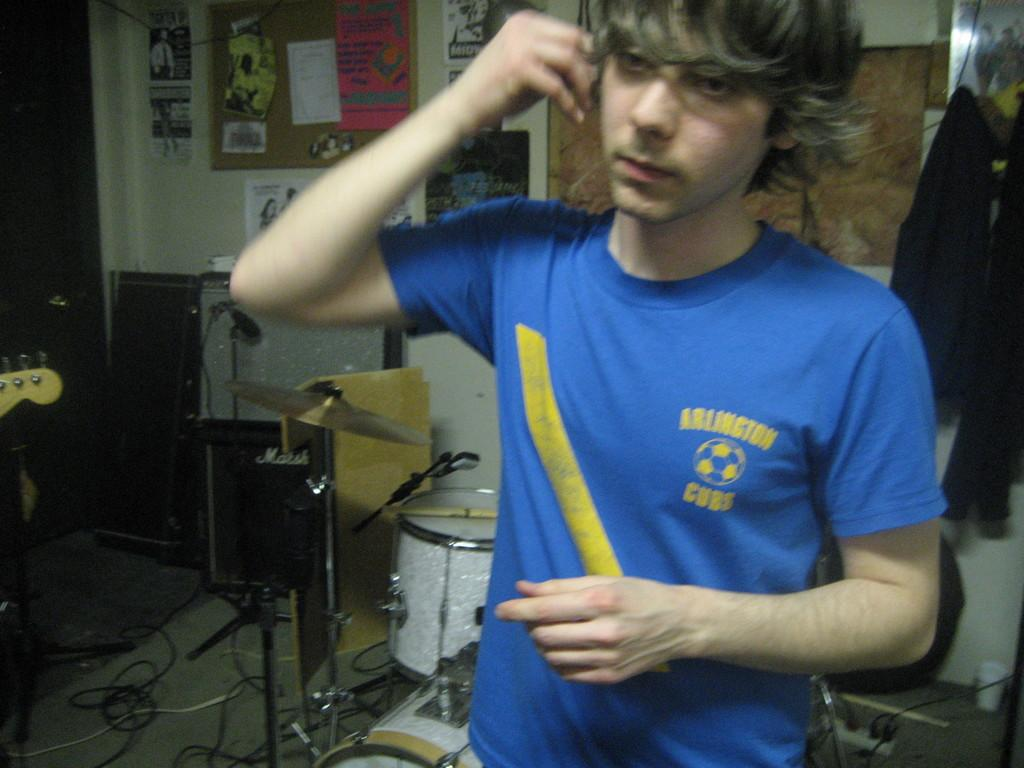<image>
Present a compact description of the photo's key features. The musician plays for the Arlington Cubs band. 